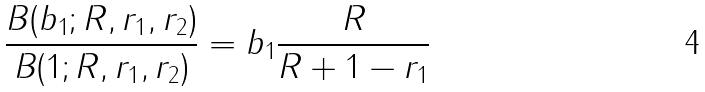Convert formula to latex. <formula><loc_0><loc_0><loc_500><loc_500>\frac { B ( b _ { 1 } ; R , r _ { 1 } , r _ { 2 } ) } { B ( 1 ; R , r _ { 1 } , r _ { 2 } ) } = b _ { 1 } \frac { R } { R + 1 - r _ { 1 } }</formula> 